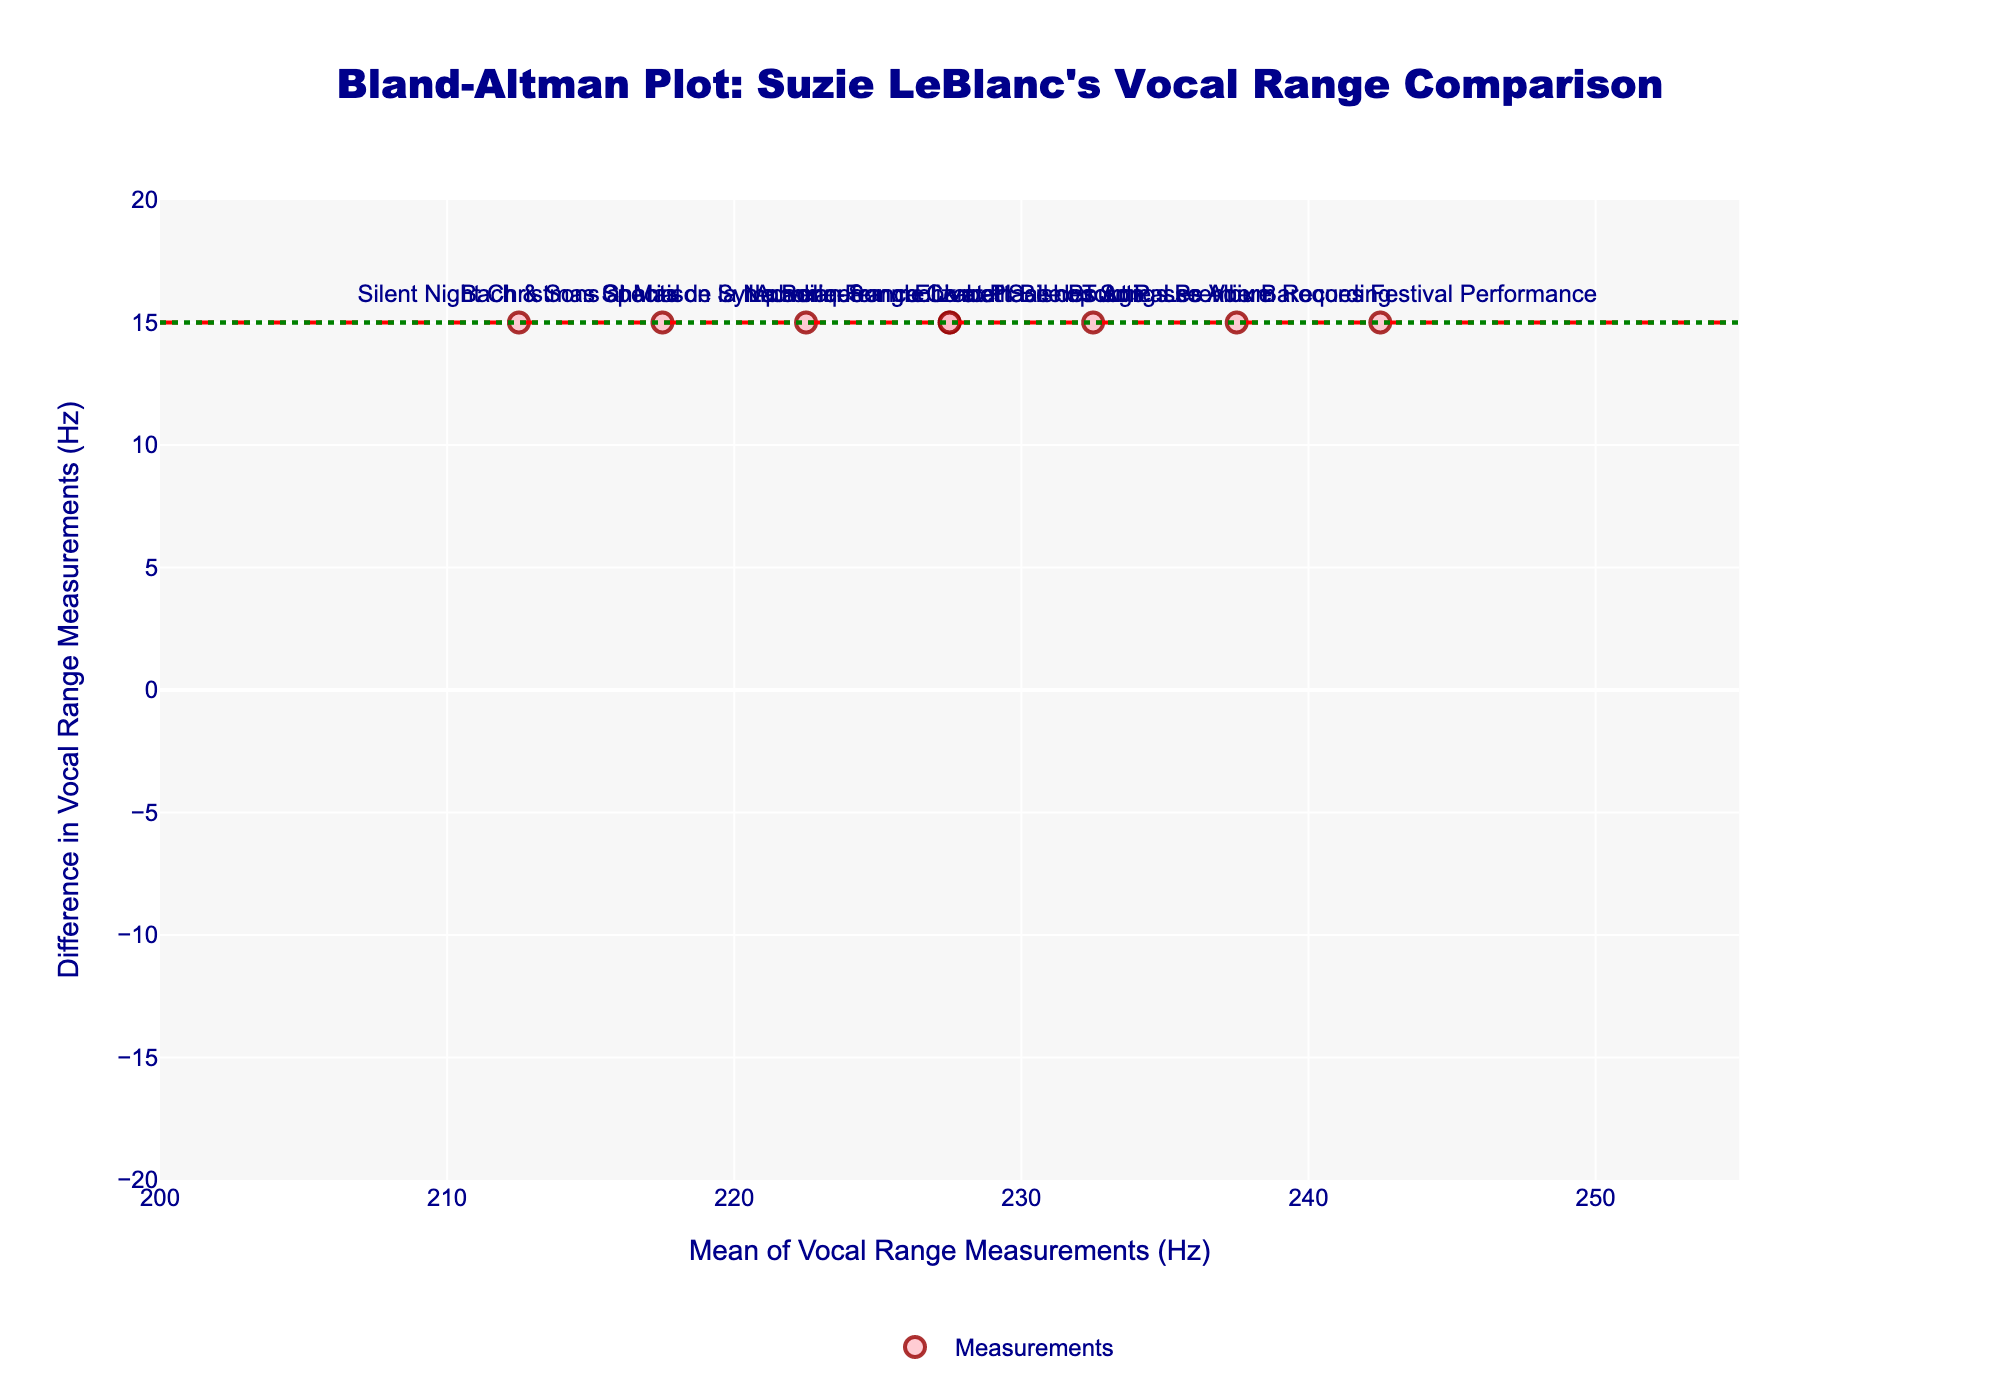What is the title of the plot? The title of the plot is clearly stated at the top and usually is larger in font size compared to other textual elements in the figure. The title reads: "Bland-Altman Plot: Suzie LeBlanc's Vocal Range Comparison".
Answer: Bland-Altman Plot: Suzie LeBlanc's Vocal Range Comparison How many performances are analyzed in the plot? Count the number of data points or markers in the Bland-Altman plot, each representing one performance. There are 8 markers visible in the figure.
Answer: 8 What is the mean difference of vocal range measurements? The mean difference is represented by a horizontal dashed red line, and its value can be read off the y-axis at the level where this line intersects.
Answer: 15 Hz What is the range of the x-axis? The range of the x-axis can be found by looking at the axis labels from the minimum to the maximum. The x-axis spans from 200 Hz to 255 Hz.
Answer: 200 Hz to 255 Hz Which performance shows the largest difference in vocal range measurements? Inspect the markers to find the one with the maximum vertical distance from the horizontal axis. The performance with the largest difference is "Silent Night" Christmas Special, where the difference is the greatest.
Answer: "Silent Night" Christmas Special What is the value of the upper limit of agreement (Upper LoA)? The upper limit of agreement is shown by a horizontal dotted green line, and its value can be read off the y-axis at the intersection of this line.
Answer: 10.4 Hz What is the overall trend shown by the mean of vocal range measurements (x-axis) versus the difference in vocal range measurements (y-axis)? The Bland-Altman plot does not indicate a systematic trend such as a proportional bias, as the points are dispersed without a specific pattern.
Answer: No systematic trend Between which two performances is the difference in vocal range measurements the smallest? Identify the smallest vertical distance from the horizontal axis and find the corresponding performance labels. The smallest difference occurs between "La Bonnefemme" Live at Salle Bourgie and "Acadian Songbook" at Place des Arts.
Answer: "La Bonnefemme" Live at Salle Bourgie and "Acadian Songbook" at Place des Arts Is any performance beyond the limits of agreement? Compare the vertical positions of all markers with the positions of the upper and lower limits of agreement lines. No performance markers exceed these dotted lines.
Answer: No What is the calculated standard deviation of the vocal range differences? The standard deviation is used in determining the limits of agreement, though not directly labeled in the plot. If the Upper LoA is given by the mean difference + 1.96*std_diff, you can solve for std_diff given that Upper LoA is 10.4 Hz and mean difference is 15 Hz: (10.4 = 15 + 1.96*std_diff). Solving the equation (std_diff * 1.96 = 4.6) gives the standard deviation.
Answer: 2.35 Hz 